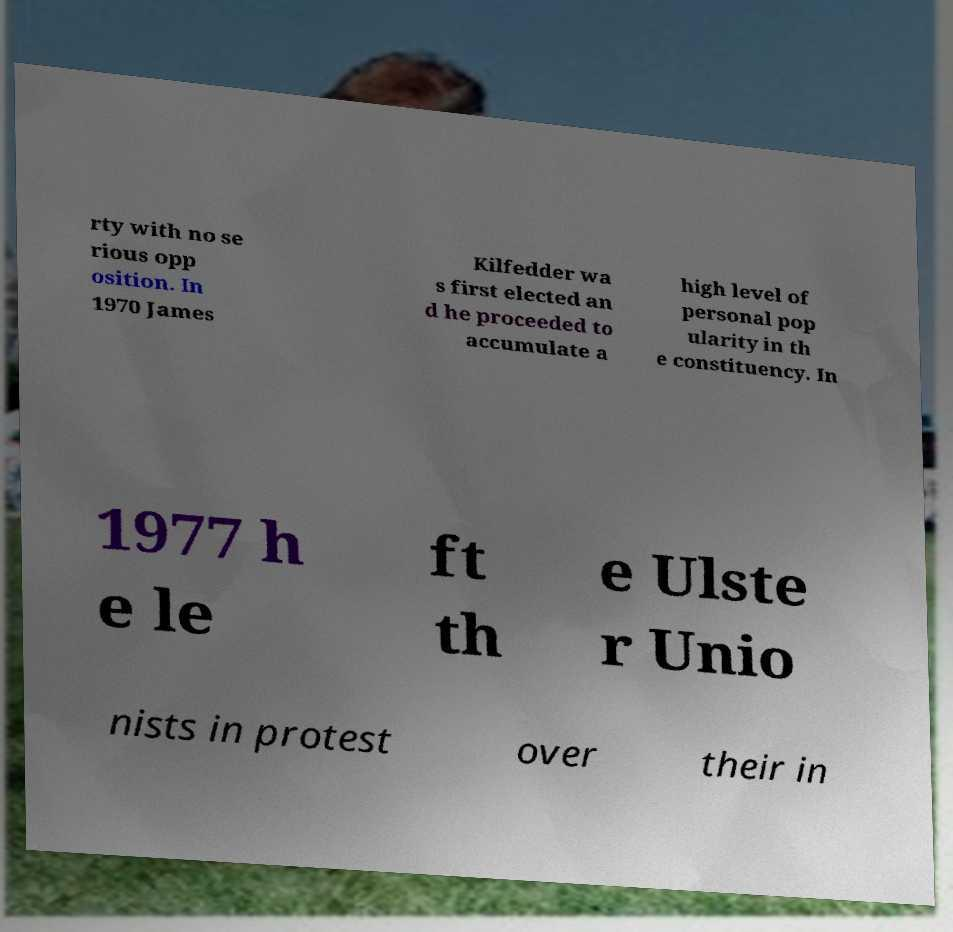Please identify and transcribe the text found in this image. rty with no se rious opp osition. In 1970 James Kilfedder wa s first elected an d he proceeded to accumulate a high level of personal pop ularity in th e constituency. In 1977 h e le ft th e Ulste r Unio nists in protest over their in 